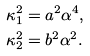<formula> <loc_0><loc_0><loc_500><loc_500>\kappa _ { 1 } ^ { 2 } & = a ^ { 2 } \alpha ^ { 4 } , \\ \kappa _ { 2 } ^ { 2 } & = b ^ { 2 } \alpha ^ { 2 } .</formula> 